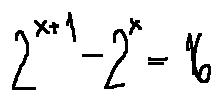<formula> <loc_0><loc_0><loc_500><loc_500>2 ^ { x + 1 } - 2 ^ { x } = 1 6</formula> 